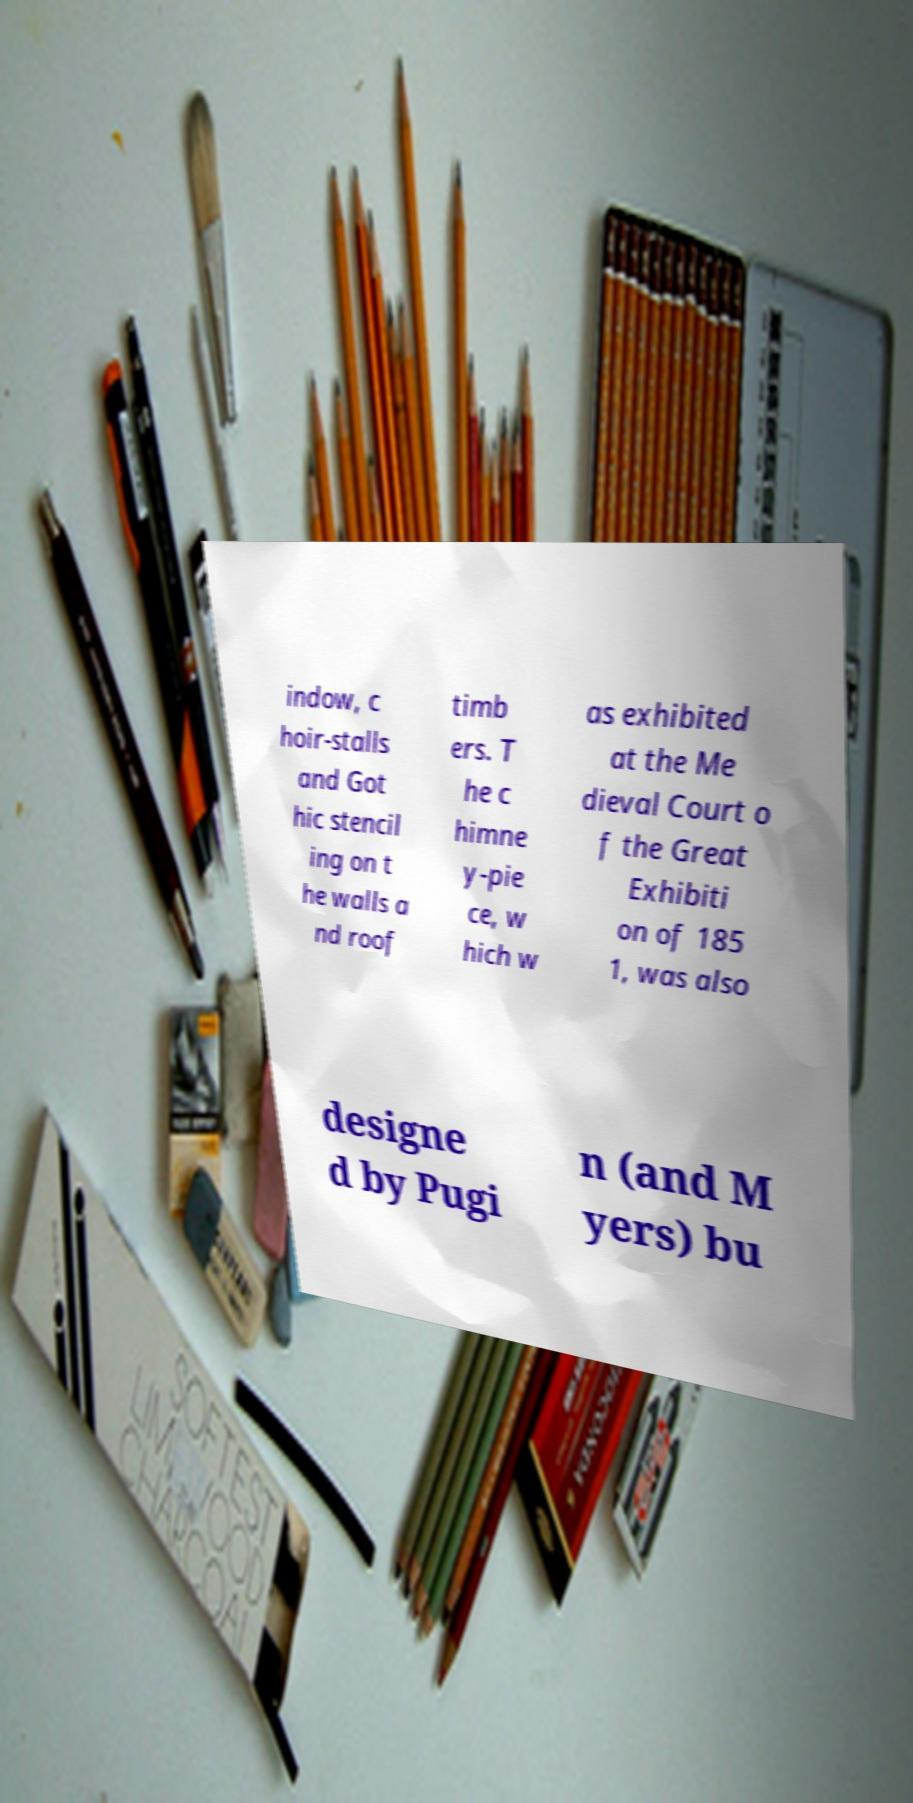For documentation purposes, I need the text within this image transcribed. Could you provide that? indow, c hoir-stalls and Got hic stencil ing on t he walls a nd roof timb ers. T he c himne y-pie ce, w hich w as exhibited at the Me dieval Court o f the Great Exhibiti on of 185 1, was also designe d by Pugi n (and M yers) bu 